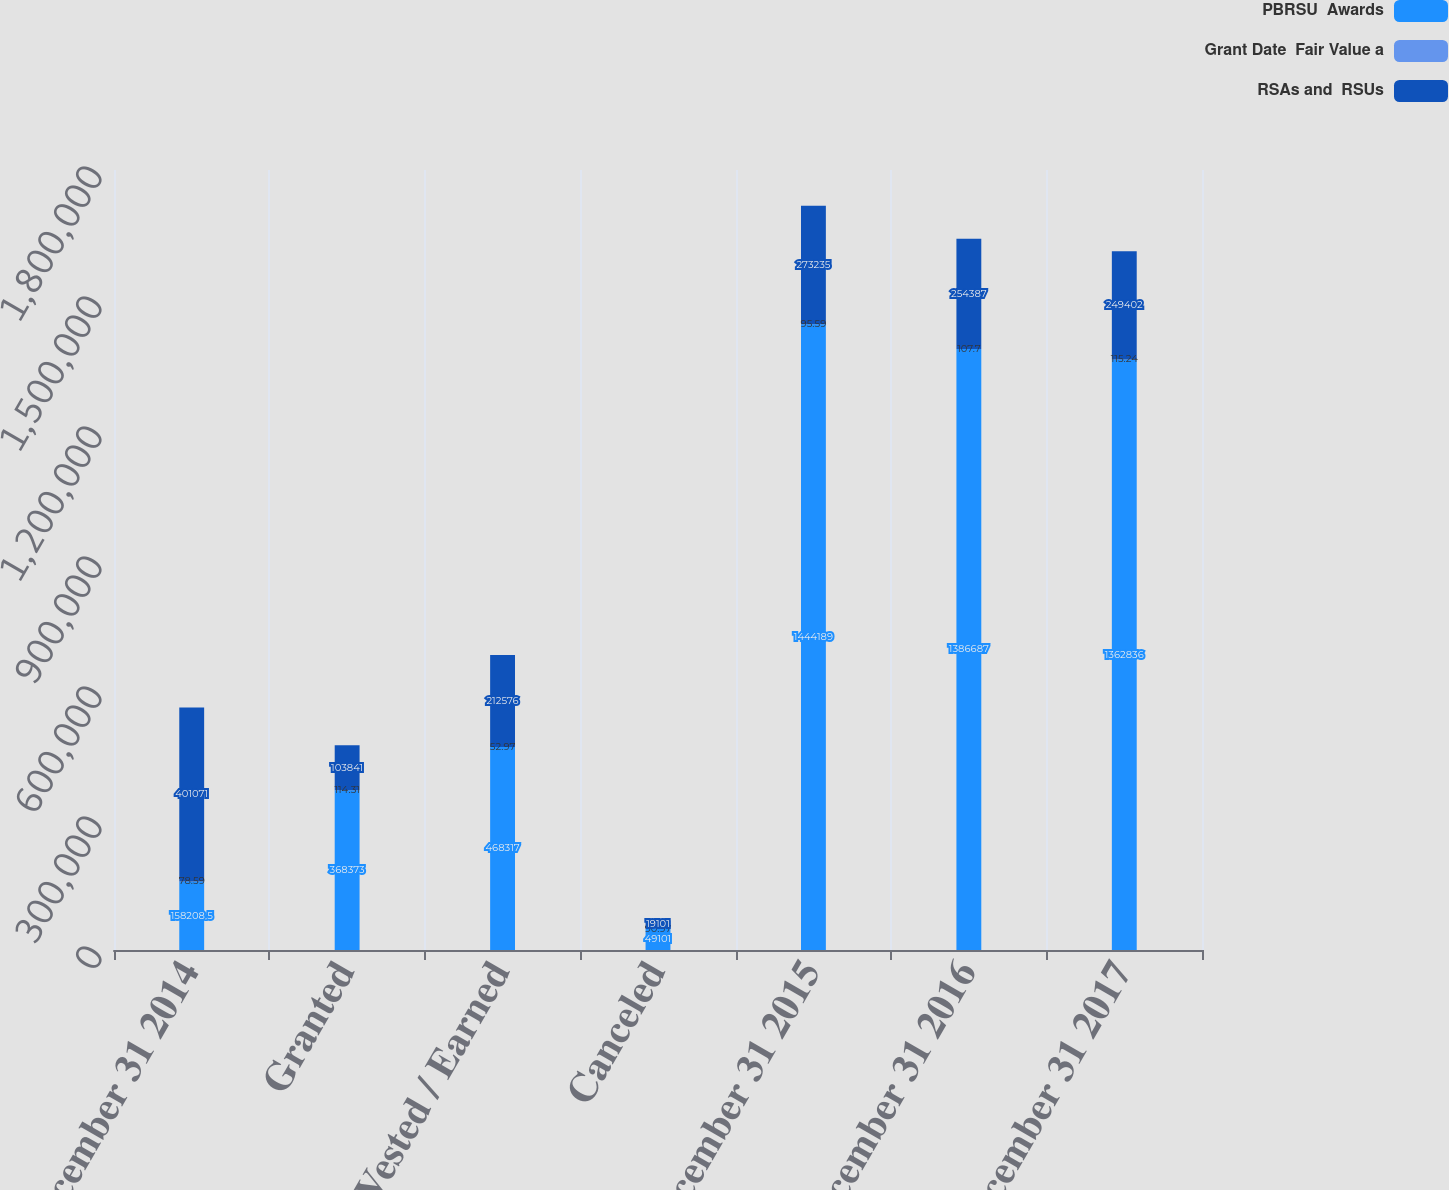<chart> <loc_0><loc_0><loc_500><loc_500><stacked_bar_chart><ecel><fcel>December 31 2014<fcel>Granted<fcel>Vested / Earned<fcel>Canceled<fcel>December 31 2015<fcel>December 31 2016<fcel>December 31 2017<nl><fcel>PBRSU  Awards<fcel>158208<fcel>368373<fcel>468317<fcel>49101<fcel>1.44419e+06<fcel>1.38669e+06<fcel>1.36284e+06<nl><fcel>Grant Date  Fair Value a<fcel>78.59<fcel>114.31<fcel>52.97<fcel>90.97<fcel>95.59<fcel>107.7<fcel>115.24<nl><fcel>RSAs and  RSUs<fcel>401071<fcel>103841<fcel>212576<fcel>19101<fcel>273235<fcel>254387<fcel>249402<nl></chart> 